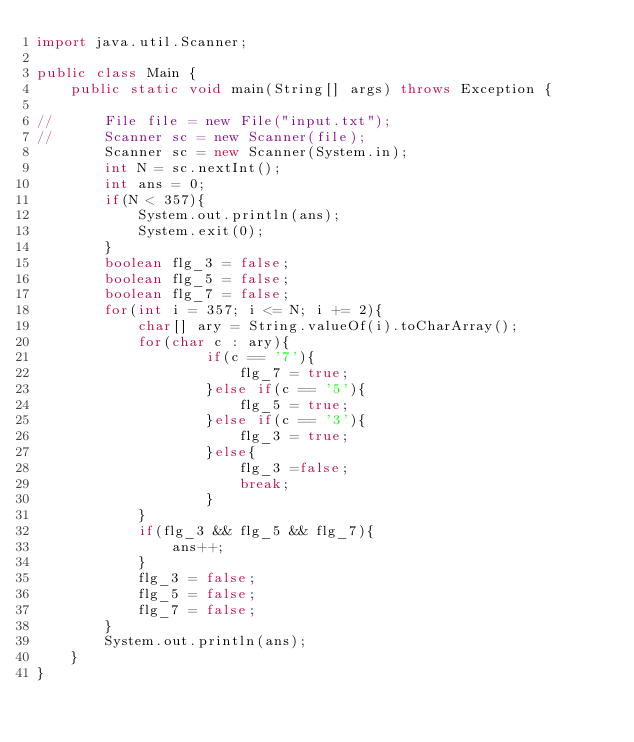Convert code to text. <code><loc_0><loc_0><loc_500><loc_500><_Java_>import java.util.Scanner;

public class Main {
    public static void main(String[] args) throws Exception {

//    	File file = new File("input.txt");
//    	Scanner sc = new Scanner(file);
    	Scanner sc = new Scanner(System.in);
    	int N = sc.nextInt();
    	int ans = 0;
    	if(N < 357){
    		System.out.println(ans);
    		System.exit(0);
    	}
    	boolean flg_3 = false;
    	boolean flg_5 = false;
    	boolean flg_7 = false;
    	for(int i = 357; i <= N; i += 2){
    		char[] ary = String.valueOf(i).toCharArray();
    		for(char c : ary){
    				if(c == '7'){
        				flg_7 = true;
        			}else if(c == '5'){
        				flg_5 = true;
        			}else if(c == '3'){
        				flg_3 = true;
        			}else{
        				flg_3 =false;
        				break;
        			}
    		}
    		if(flg_3 && flg_5 && flg_7){
    			ans++;
    		}
    		flg_3 = false;
    		flg_5 = false;
    		flg_7 = false;
    	}
    	System.out.println(ans);
    }
}</code> 